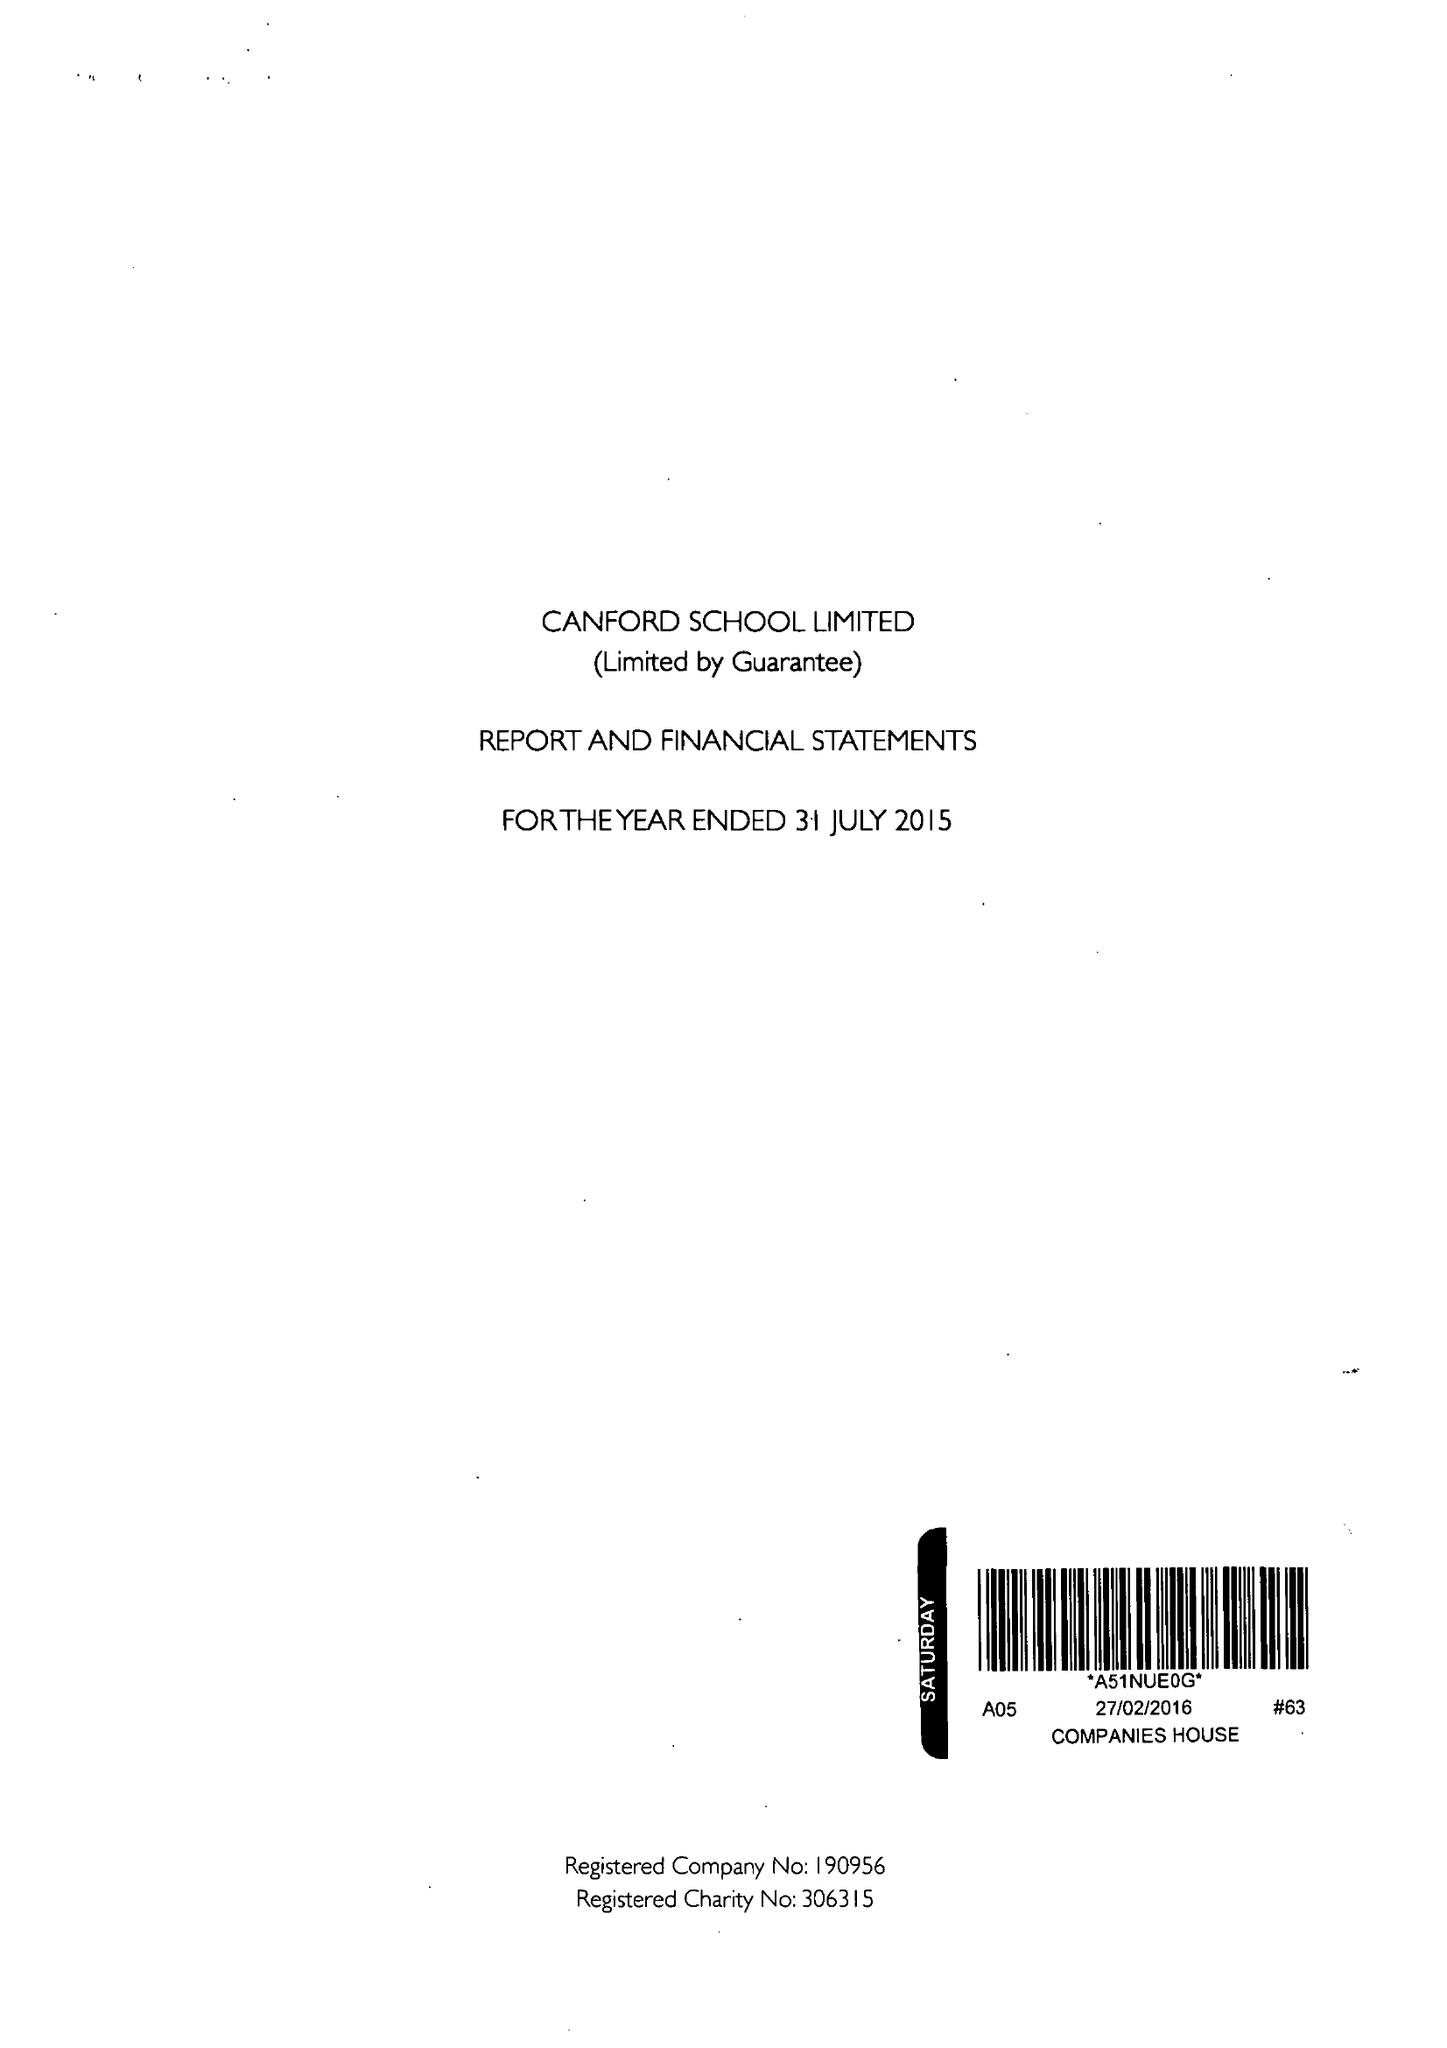What is the value for the address__street_line?
Answer the question using a single word or phrase. CANFORD MAGNA 